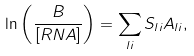Convert formula to latex. <formula><loc_0><loc_0><loc_500><loc_500>\ln \left ( \frac { B } { [ R N A ] } \right ) = \sum _ { l i } S _ { l i } A _ { l i } ,</formula> 